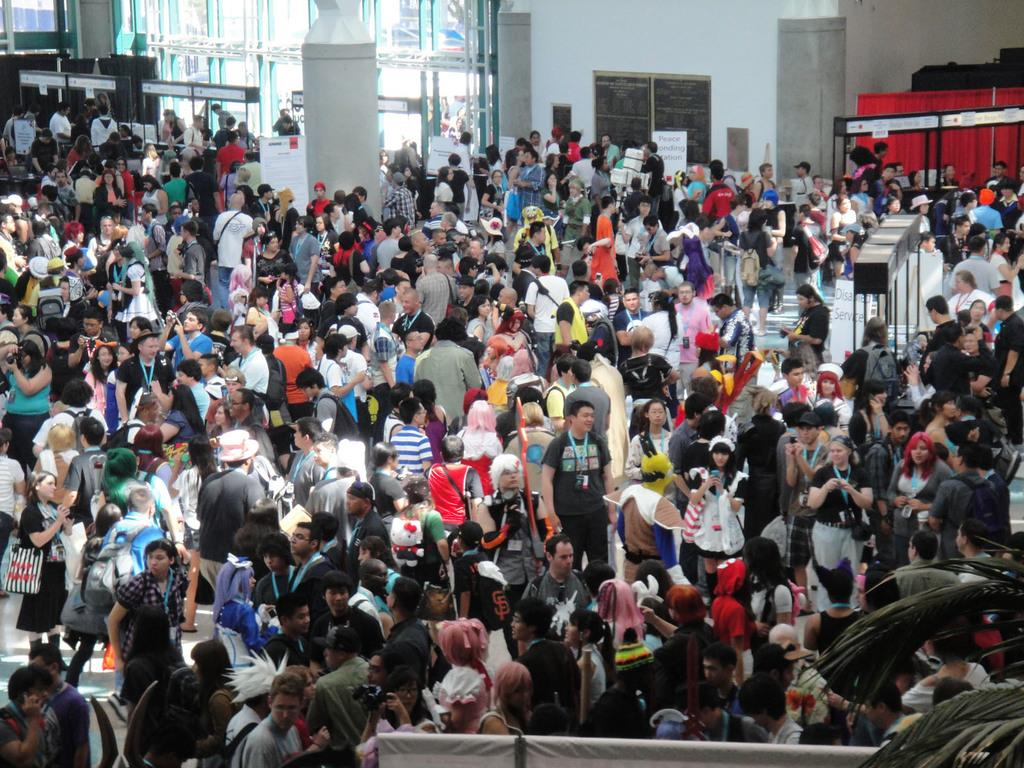What type of natural elements can be seen in the image? There are leaves in the image. What is the composition of the group of people in the image? There is a group of people standing in the image. What items are present that might be used for carrying belongings? Bags are present in the image. What type of printed materials can be seen in the image? Posters are visible in the image. Can you describe any other objects in the image? There are other objects in the image, but their specific details are not mentioned in the provided facts. What is visible in the background of the image? There is a wall in the background of the image. What type of beam is being used by the people in the image? There is no beam present in the image; it features a group of people standing, bags, posters, and a wall in the background. What type of skin condition is visible on the people in the image? There is no indication of any skin condition visible on the people in the image. 